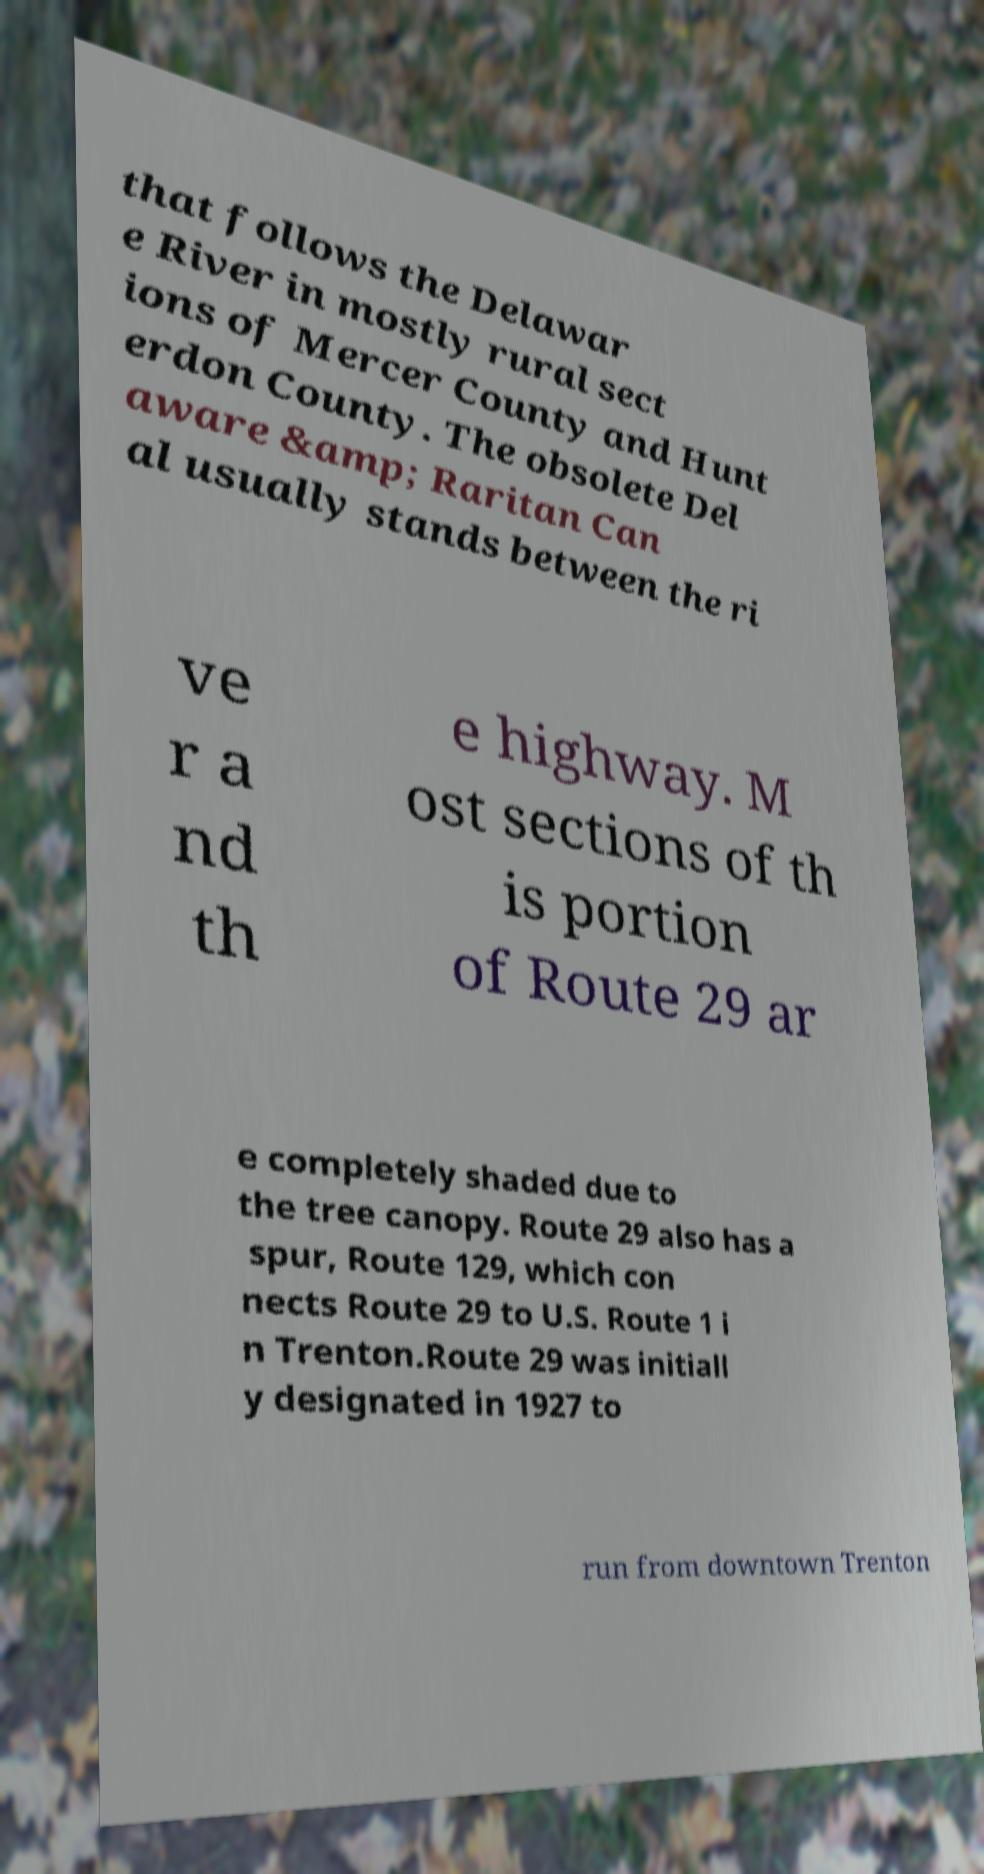There's text embedded in this image that I need extracted. Can you transcribe it verbatim? that follows the Delawar e River in mostly rural sect ions of Mercer County and Hunt erdon County. The obsolete Del aware &amp; Raritan Can al usually stands between the ri ve r a nd th e highway. M ost sections of th is portion of Route 29 ar e completely shaded due to the tree canopy. Route 29 also has a spur, Route 129, which con nects Route 29 to U.S. Route 1 i n Trenton.Route 29 was initiall y designated in 1927 to run from downtown Trenton 